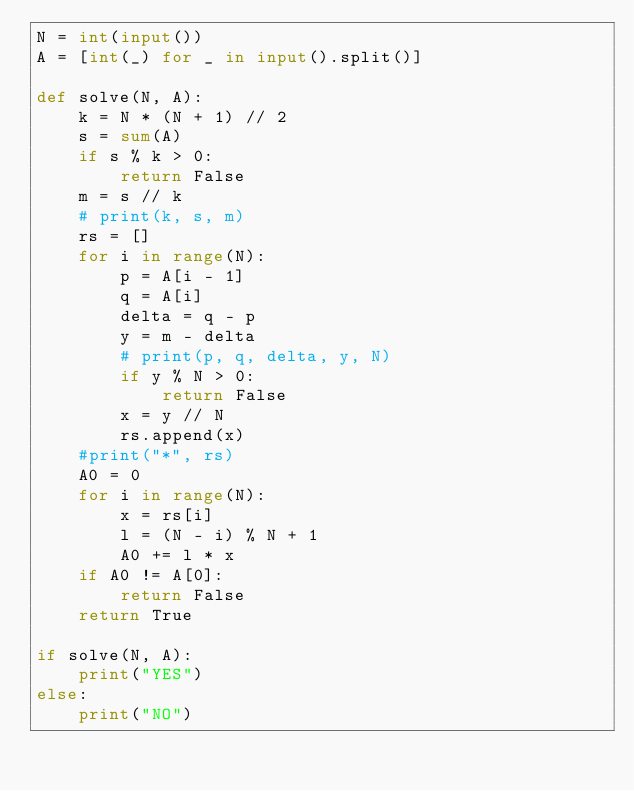Convert code to text. <code><loc_0><loc_0><loc_500><loc_500><_Python_>N = int(input())
A = [int(_) for _ in input().split()]

def solve(N, A):
    k = N * (N + 1) // 2
    s = sum(A)
    if s % k > 0:
        return False
    m = s // k
    # print(k, s, m)
    rs = []
    for i in range(N):
        p = A[i - 1]
        q = A[i]
        delta = q - p
        y = m - delta
        # print(p, q, delta, y, N)
        if y % N > 0:
            return False
        x = y // N
        rs.append(x)
    #print("*", rs)
    A0 = 0
    for i in range(N):
        x = rs[i]
        l = (N - i) % N + 1
        A0 += l * x
    if A0 != A[0]:
        return False
    return True

if solve(N, A):
    print("YES")
else:
    print("NO")
</code> 